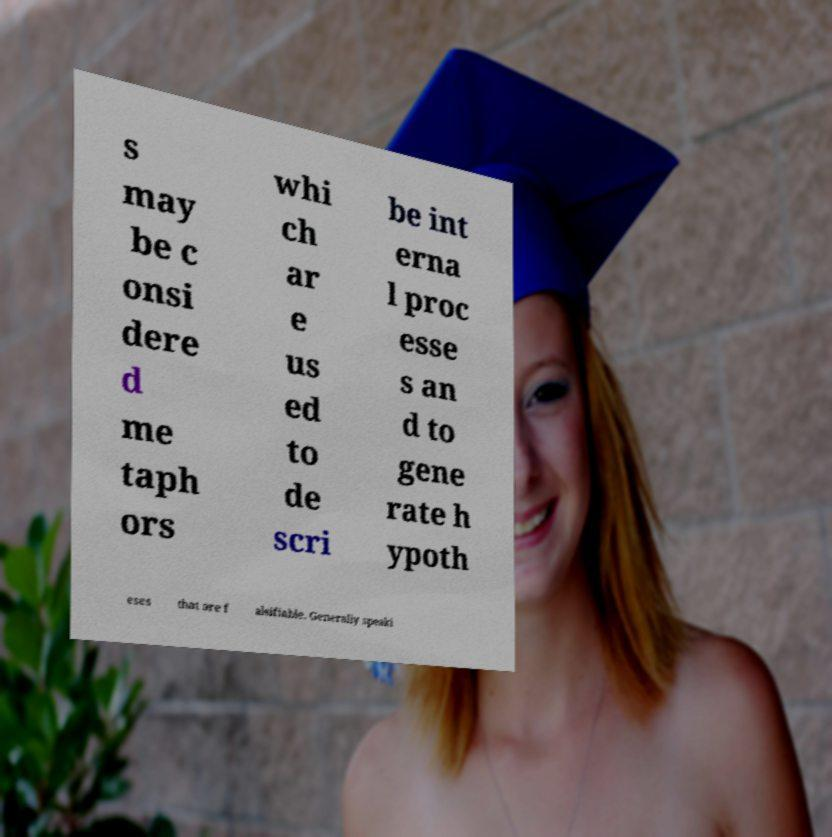Could you extract and type out the text from this image? s may be c onsi dere d me taph ors whi ch ar e us ed to de scri be int erna l proc esse s an d to gene rate h ypoth eses that are f alsifiable. Generally speaki 